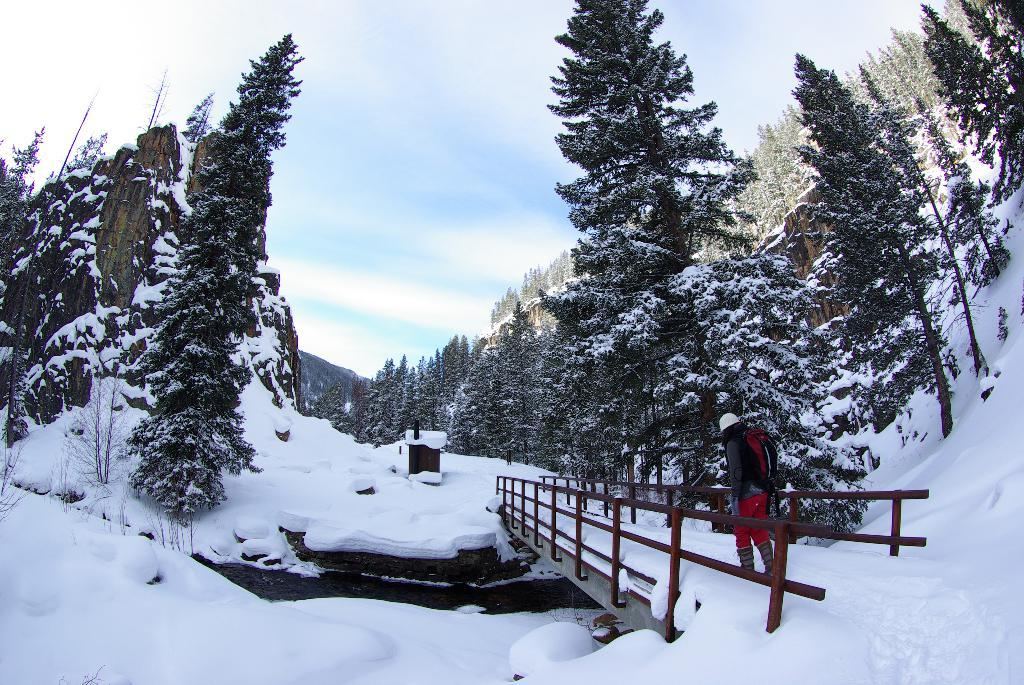What is the person in the image standing on? The person is standing on a bridge. What is the condition of the bridge in the image? The bridge is covered with snow. What can be seen in the background of the image? There are trees and mountains in the background of the image. What is the condition of the trees and mountains in the image? The trees and mountains are covered with snow. What type of celery can be seen growing near the bridge in the image? There is no celery present in the image. How does the pollution affect the snow-covered mountains in the image? There is no mention of pollution in the image, so we cannot determine its effect on the snow-covered mountains. 